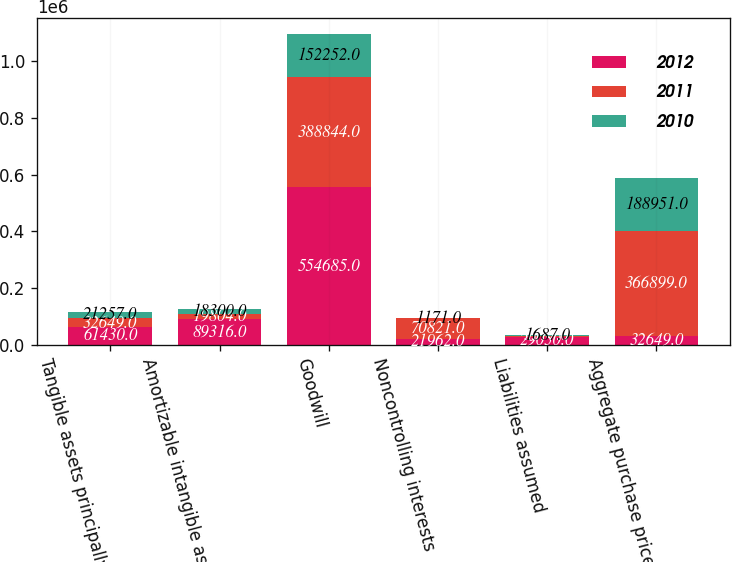Convert chart. <chart><loc_0><loc_0><loc_500><loc_500><stacked_bar_chart><ecel><fcel>Tangible assets principally<fcel>Amortizable intangible assets<fcel>Goodwill<fcel>Noncontrolling interests<fcel>Liabilities assumed<fcel>Aggregate purchase price<nl><fcel>2012<fcel>61430<fcel>89316<fcel>554685<fcel>21962<fcel>29050<fcel>32649<nl><fcel>2011<fcel>32649<fcel>19804<fcel>388844<fcel>70821<fcel>3577<fcel>366899<nl><fcel>2010<fcel>21257<fcel>18300<fcel>152252<fcel>1171<fcel>1687<fcel>188951<nl></chart> 